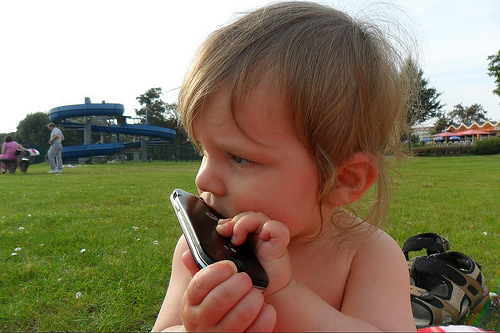Can you describe the setting where the child is? The child is sitting on a grassy field dotted with small flowers, indicating a day spent outdoors, perhaps in a park. In the background, partially out of focus, there's an impression of a recreational or playground area with structures possibly meant for play. It's an idyllic scene evoking leisure and playfulness. 